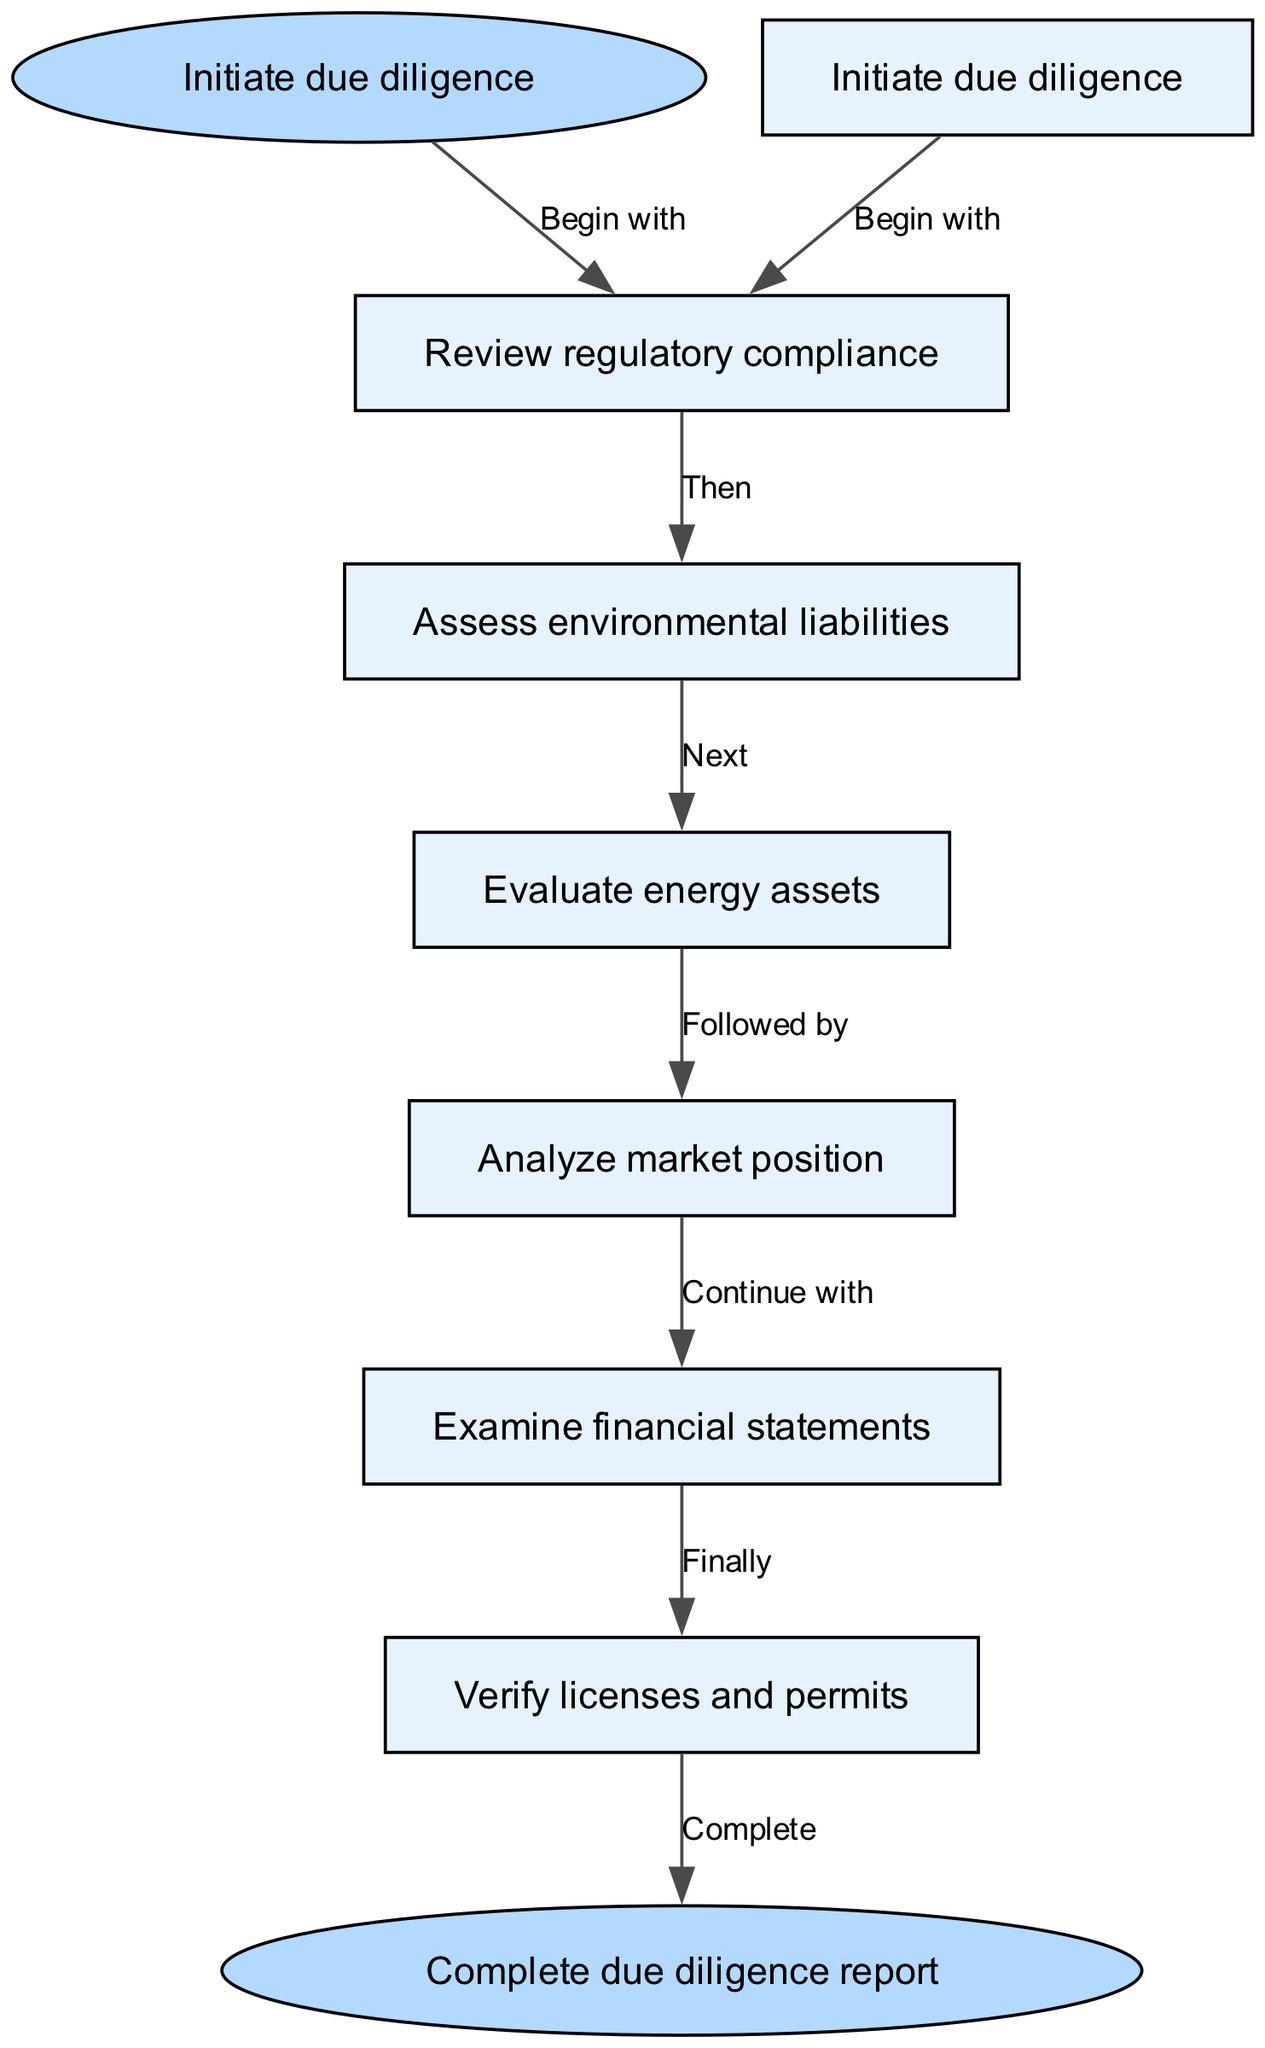What is the first step in the due diligence procedure? The diagram indicates that the first step is "Initiate due diligence." This is represented as the start node in the flow chart.
Answer: Initiate due diligence How many nodes are present in the diagram? The diagram includes one start node, five intermediate nodes, and one end node. Adding them together gives a total of seven nodes.
Answer: 7 What is the last step before completing the due diligence report? According to the diagram, the last step before completion is "Verify licenses and permits." This is the final task performed before moving to the end node.
Answer: Verify licenses and permits What node follows "Analyze market position"? The diagram shows that the node "Examine financial statements" follows "Analyze market position," as indicated by the directed edge connecting them in the flow of the process.
Answer: Examine financial statements Which node leads directly to "Assess environmental liabilities"? The flow chart indicates that "Review regulatory compliance" is the node that leads directly to "Assess environmental liabilities," as there is an edge going from the former to the latter.
Answer: Review regulatory compliance What is the relationship between "Evaluate energy assets" and "Complete due diligence report"? The relationship is that "Evaluate energy assets" is an intermediate step that must be completed before progressing to the end node "Complete due diligence report," as evidenced by the ordered sequence in the flow chart.
Answer: Intermediate step What is the sequence of the due diligence steps from start to finish? The sequence is as follows: "Initiate due diligence," "Review regulatory compliance," "Assess environmental liabilities," "Evaluate energy assets," "Analyze market position," "Examine financial statements," and finally "Verify licenses and permits" before "Complete due diligence report." This represents the entire flow from start to end.
Answer: Initiate due diligence, Review regulatory compliance, Assess environmental liabilities, Evaluate energy assets, Analyze market position, Examine financial statements, Verify licenses and permits How many edges are there in the diagram? Each step in the due diligence process is connected by a directed edge. There are a total of six edges based on the transitions between each step in the flow.
Answer: 6 What step is labeled as "Finally" in the process? The diagram designates "Verify licenses and permits" as the step labeled "Finally," indicating this is the last process step before completing the report.
Answer: Verify licenses and permits 